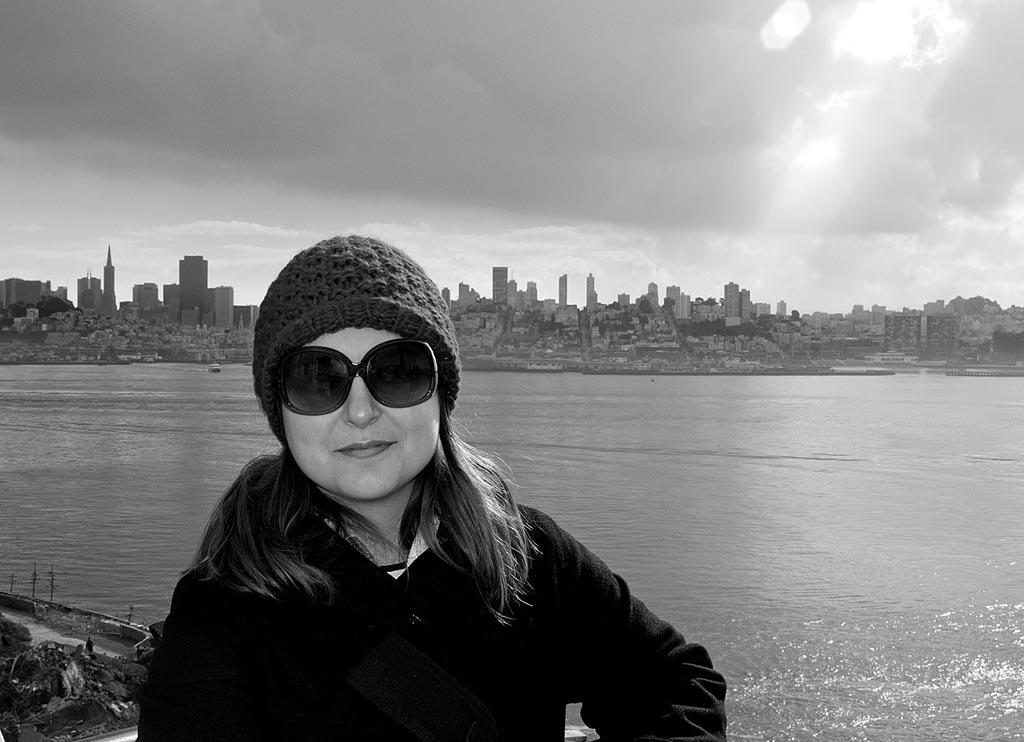What is the color scheme of the image? The image is black and white. Who is present in the image? There is a woman in the image. What is the woman wearing? The woman is wearing clothes, goggles, and a cap. What is the woman's facial expression? The woman is smiling. What natural feature can be seen in the image? The sea is visible in the image. What man-made structures are present in the image? There are buildings in the image. How would you describe the weather in the image? The sky is cloudy in the image. What committee is the woman a part of in the image? There is no indication in the image that the woman is a part of any committee. What rule does the woman need to follow while wearing the goggles in the image? There is no rule mentioned or implied in the image regarding the use of goggles. 